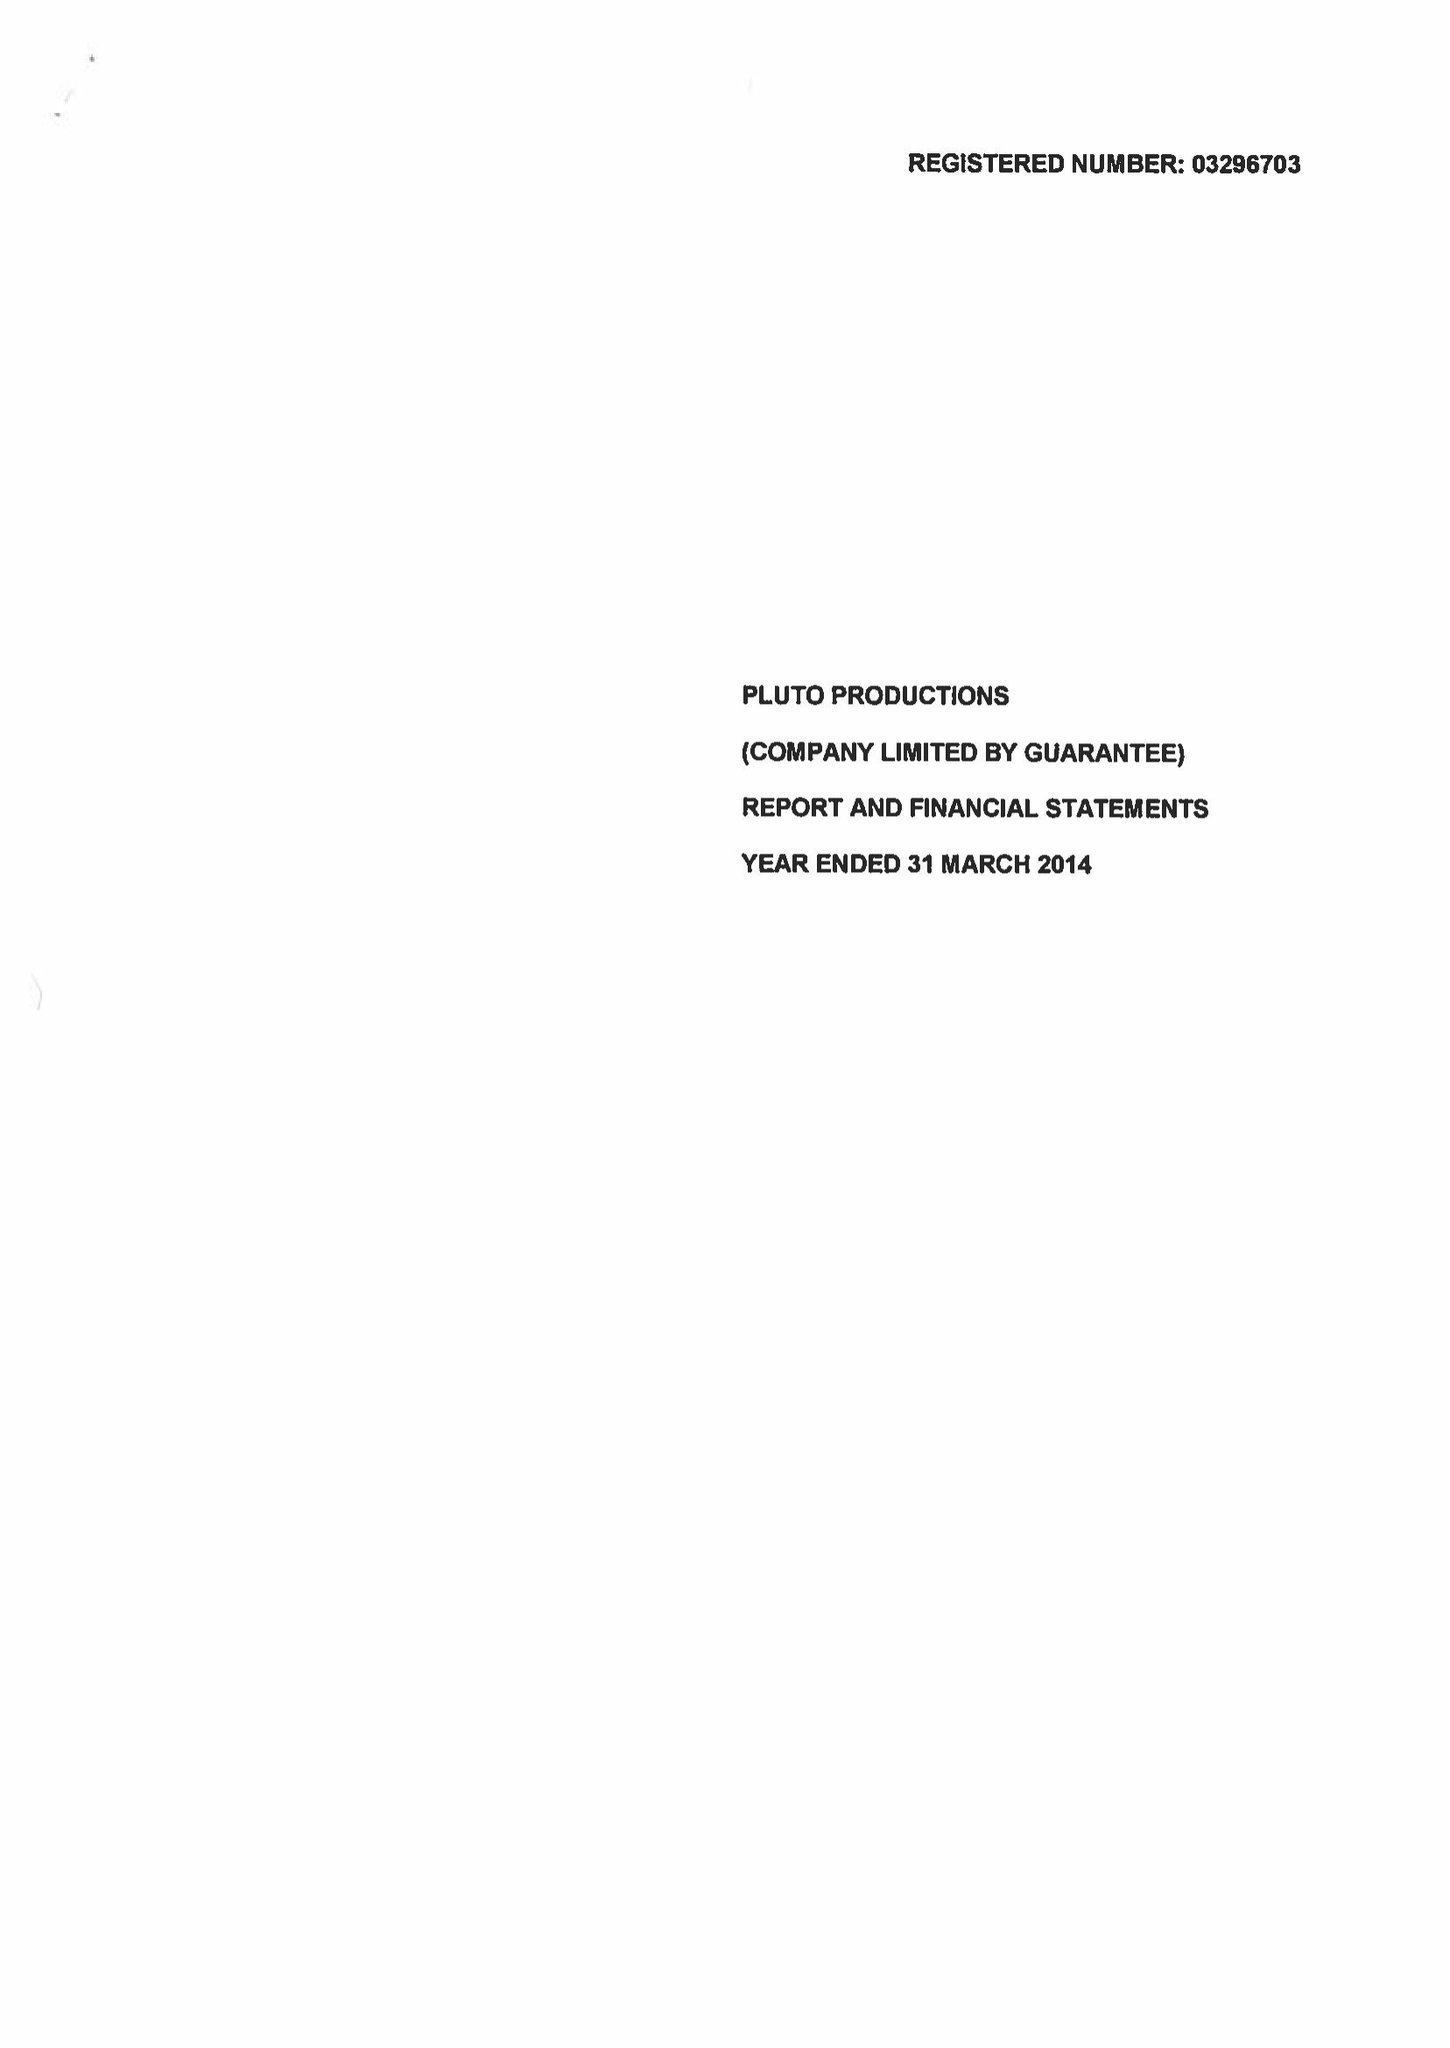What is the value for the spending_annually_in_british_pounds?
Answer the question using a single word or phrase. 77922.00 